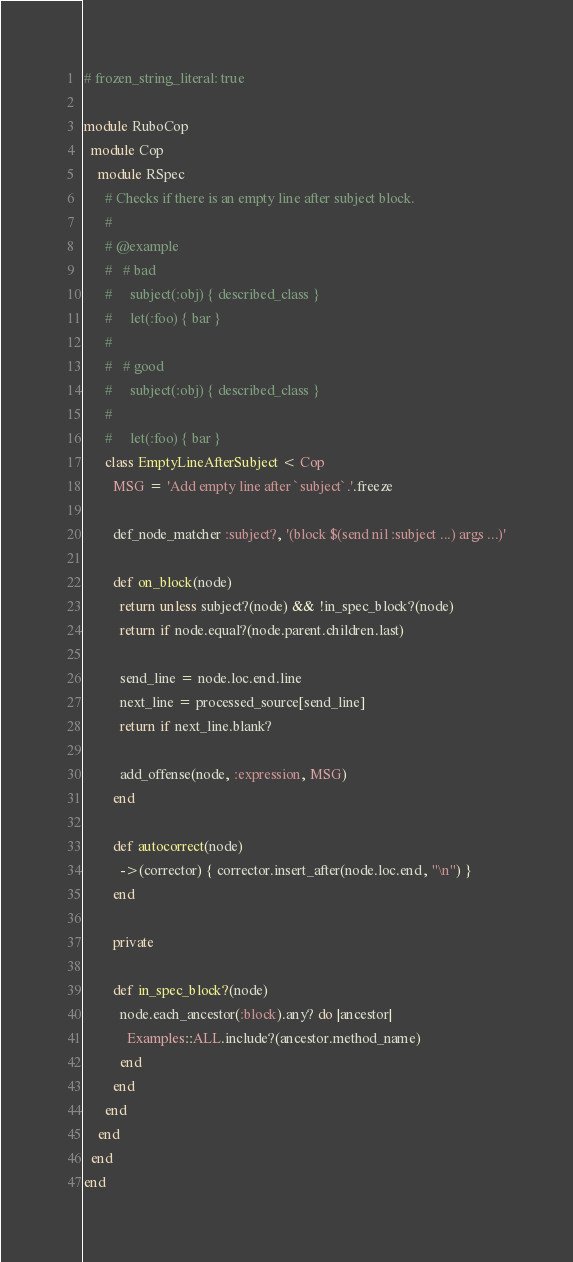Convert code to text. <code><loc_0><loc_0><loc_500><loc_500><_Ruby_># frozen_string_literal: true

module RuboCop
  module Cop
    module RSpec
      # Checks if there is an empty line after subject block.
      #
      # @example
      #   # bad
      #     subject(:obj) { described_class }
      #     let(:foo) { bar }
      #
      #   # good
      #     subject(:obj) { described_class }
      #
      #     let(:foo) { bar }
      class EmptyLineAfterSubject < Cop
        MSG = 'Add empty line after `subject`.'.freeze

        def_node_matcher :subject?, '(block $(send nil :subject ...) args ...)'

        def on_block(node)
          return unless subject?(node) && !in_spec_block?(node)
          return if node.equal?(node.parent.children.last)

          send_line = node.loc.end.line
          next_line = processed_source[send_line]
          return if next_line.blank?

          add_offense(node, :expression, MSG)
        end

        def autocorrect(node)
          ->(corrector) { corrector.insert_after(node.loc.end, "\n") }
        end

        private

        def in_spec_block?(node)
          node.each_ancestor(:block).any? do |ancestor|
            Examples::ALL.include?(ancestor.method_name)
          end
        end
      end
    end
  end
end
</code> 